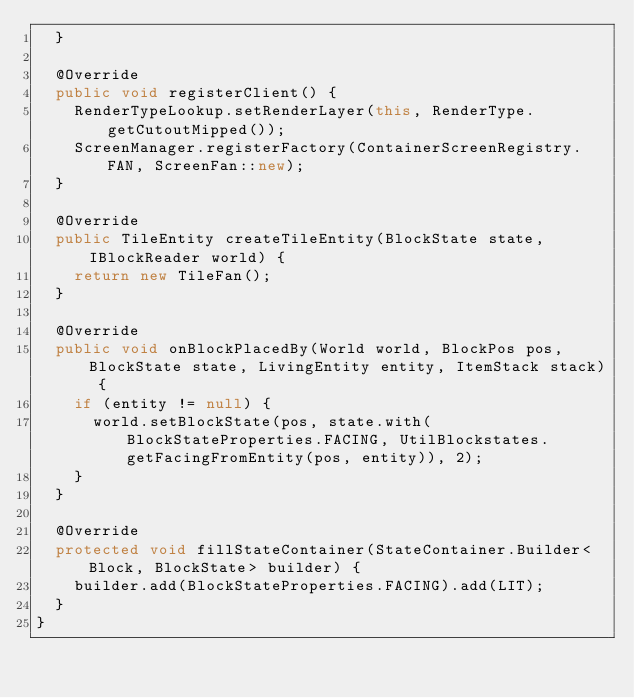<code> <loc_0><loc_0><loc_500><loc_500><_Java_>  }

  @Override
  public void registerClient() {
    RenderTypeLookup.setRenderLayer(this, RenderType.getCutoutMipped());
    ScreenManager.registerFactory(ContainerScreenRegistry.FAN, ScreenFan::new);
  }

  @Override
  public TileEntity createTileEntity(BlockState state, IBlockReader world) {
    return new TileFan();
  }

  @Override
  public void onBlockPlacedBy(World world, BlockPos pos, BlockState state, LivingEntity entity, ItemStack stack) {
    if (entity != null) {
      world.setBlockState(pos, state.with(BlockStateProperties.FACING, UtilBlockstates.getFacingFromEntity(pos, entity)), 2);
    }
  }

  @Override
  protected void fillStateContainer(StateContainer.Builder<Block, BlockState> builder) {
    builder.add(BlockStateProperties.FACING).add(LIT);
  }
}
</code> 